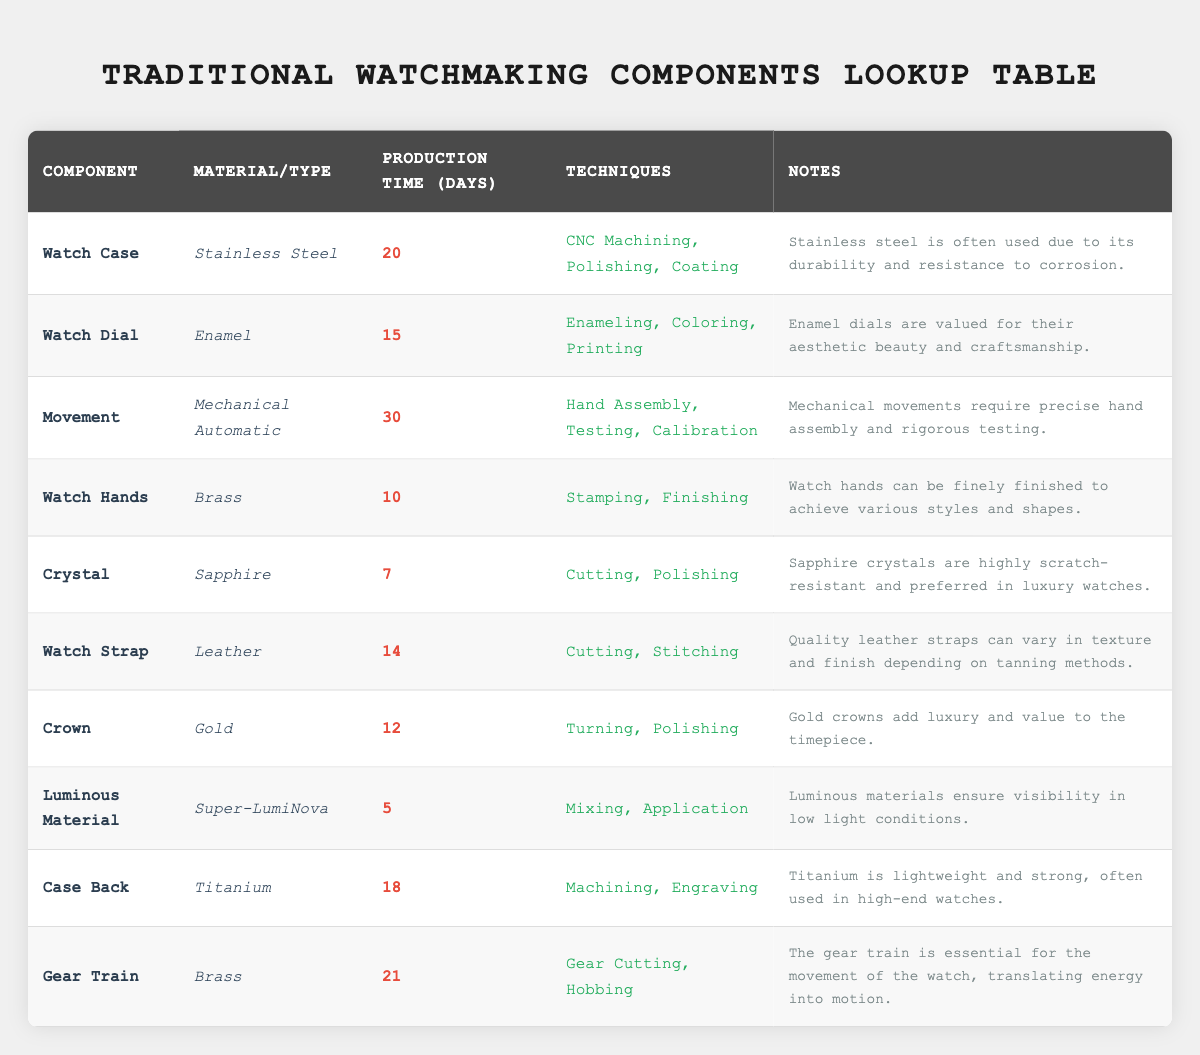What is the production time for the Watch Case? The production time for the Watch Case is specified directly in the table, as 20 days.
Answer: 20 days How many days does it take to produce a Watch Strap? The Watch Strap production time is clearly listed in the table, which indicates it takes 14 days.
Answer: 14 days Which component has the longest production time? By reviewing the production time for each component, the Movement has the longest production time at 30 days.
Answer: Movement Is it true that the Crystal component is made of Sapphire? The table states that the material for the Crystal component is Sapphire, confirming the fact.
Answer: Yes What is the average production time of the Watch Hands and the Watch Strap? The production time for Watch Hands is 10 days and for Watch Strap is 14 days. Adding them gives (10 + 14 = 24). To find the average, divide by 2, which results in 12.
Answer: 12 days Which components are made of Brass? Referring to the table, the components listed as made of Brass are Watch Hands and Gear Train.
Answer: Watch Hands, Gear Train How many components have a production time of 20 days or more? The table shows that the components with a production time of 20 days or more are Watch Case (20), Movement (30), and Gear Train (21), making a total of 3 components.
Answer: 3 components What materials are used in the production of the Crown and Case Back? The table indicates that the Crown is made of Gold and the Case Back is made of Titanium.
Answer: Gold, Titanium Is the Luminous Material production time less than 10 days? The production time for the Luminous Material is 5 days, which is indeed less than 10 days.
Answer: Yes 